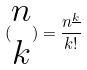<formula> <loc_0><loc_0><loc_500><loc_500>( \begin{matrix} n \\ k \end{matrix} ) = \frac { n ^ { \underline { k } } } { k ! }</formula> 